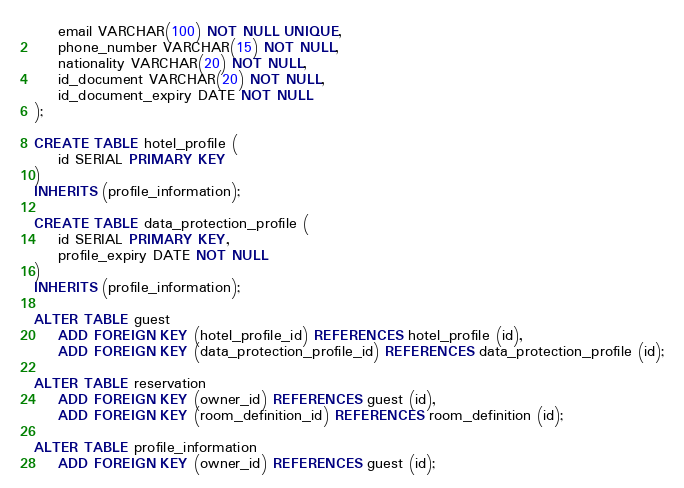<code> <loc_0><loc_0><loc_500><loc_500><_SQL_>    email VARCHAR(100) NOT NULL UNIQUE,
    phone_number VARCHAR(15) NOT NULL,
    nationality VARCHAR(20) NOT NULL,
    id_document VARCHAR(20) NOT NULL,
    id_document_expiry DATE NOT NULL
);

CREATE TABLE hotel_profile (
    id SERIAL PRIMARY KEY
)
INHERITS (profile_information);

CREATE TABLE data_protection_profile (
    id SERIAL PRIMARY KEY,
    profile_expiry DATE NOT NULL
)
INHERITS (profile_information);

ALTER TABLE guest 
    ADD FOREIGN KEY (hotel_profile_id) REFERENCES hotel_profile (id),
    ADD FOREIGN KEY (data_protection_profile_id) REFERENCES data_protection_profile (id);

ALTER TABLE reservation 
    ADD FOREIGN KEY (owner_id) REFERENCES guest (id),
    ADD FOREIGN KEY (room_definition_id) REFERENCES room_definition (id);

ALTER TABLE profile_information 
    ADD FOREIGN KEY (owner_id) REFERENCES guest (id);</code> 